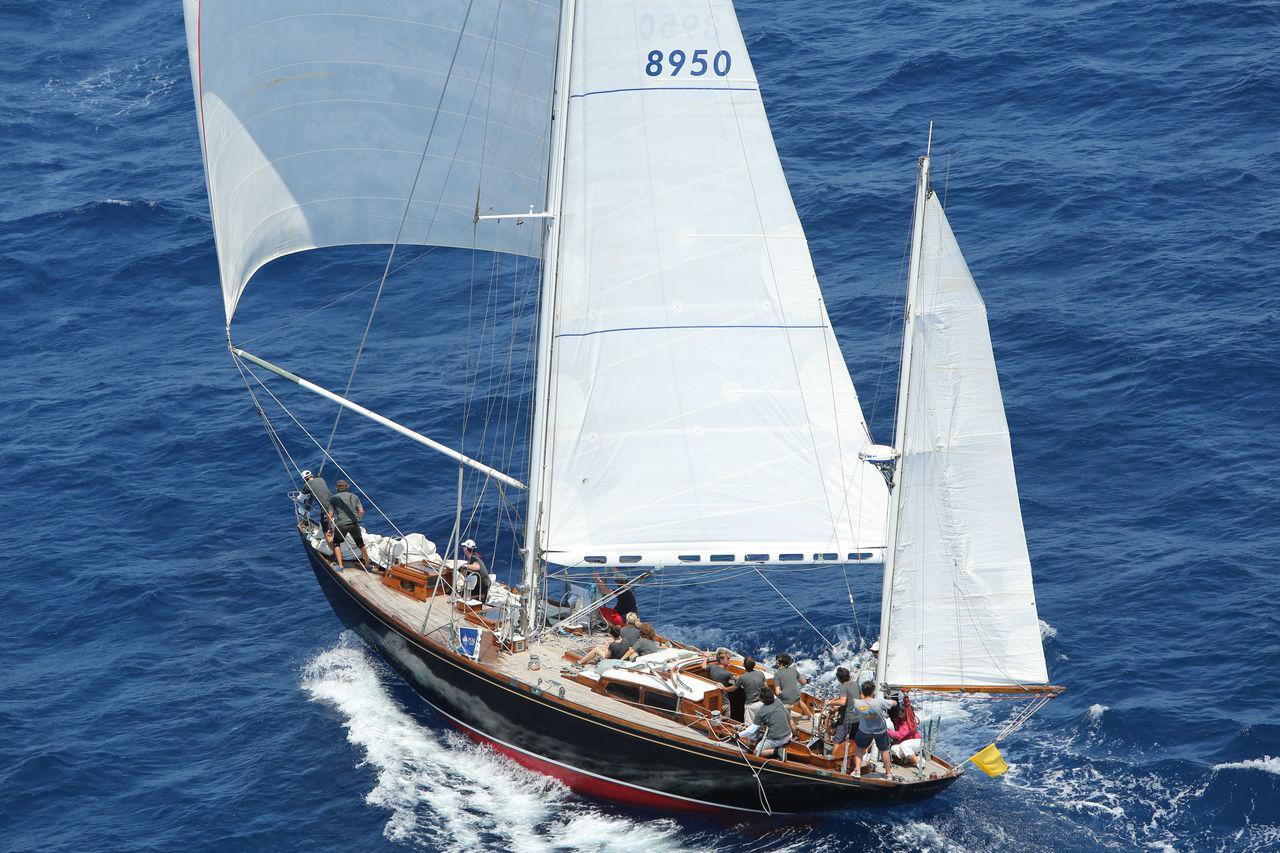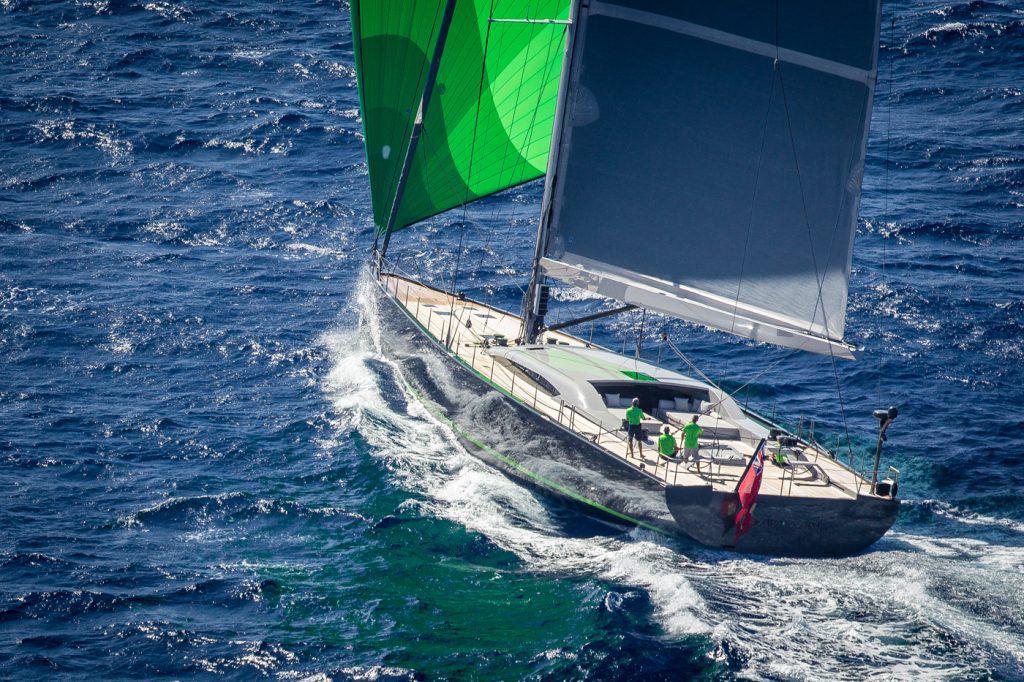The first image is the image on the left, the second image is the image on the right. For the images displayed, is the sentence "There is one sailboat without the sails unfurled." factually correct? Answer yes or no. No. 